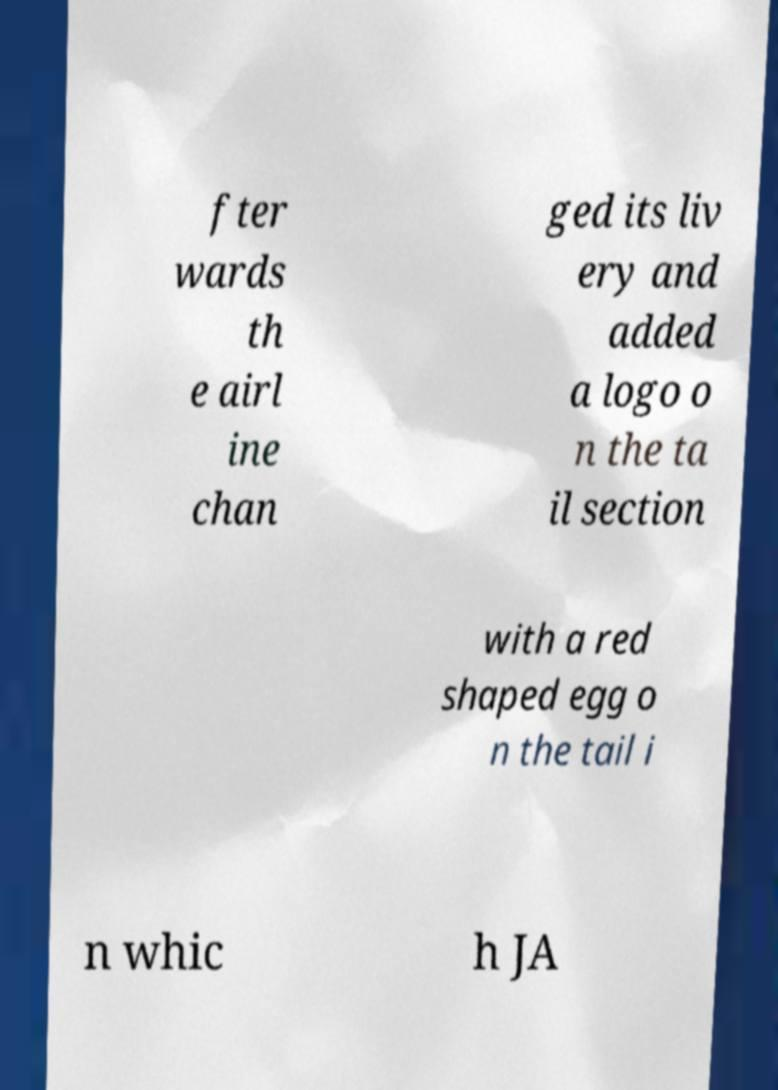Please read and relay the text visible in this image. What does it say? fter wards th e airl ine chan ged its liv ery and added a logo o n the ta il section with a red shaped egg o n the tail i n whic h JA 